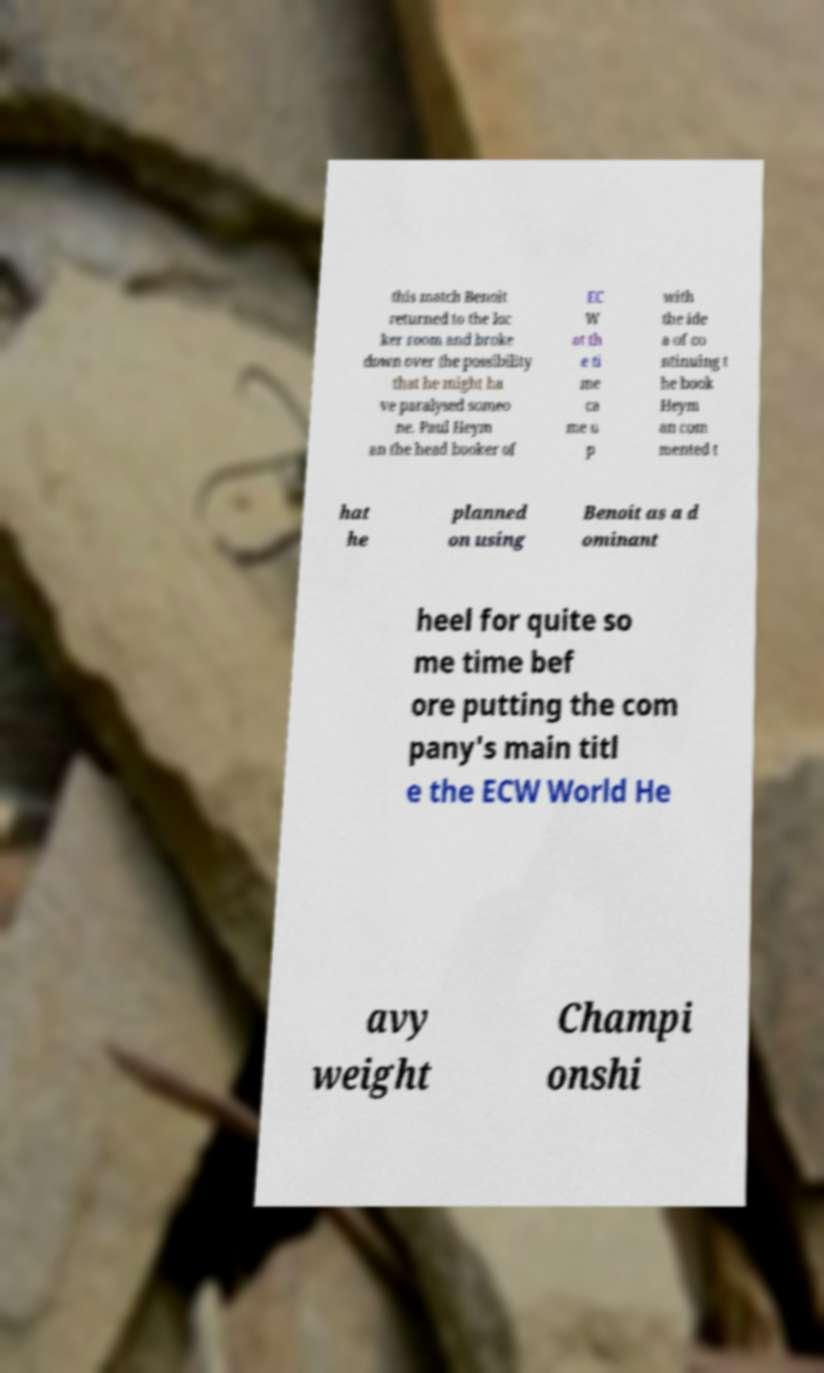What messages or text are displayed in this image? I need them in a readable, typed format. this match Benoit returned to the loc ker room and broke down over the possibility that he might ha ve paralysed someo ne. Paul Heym an the head booker of EC W at th e ti me ca me u p with the ide a of co ntinuing t he book Heym an com mented t hat he planned on using Benoit as a d ominant heel for quite so me time bef ore putting the com pany's main titl e the ECW World He avy weight Champi onshi 